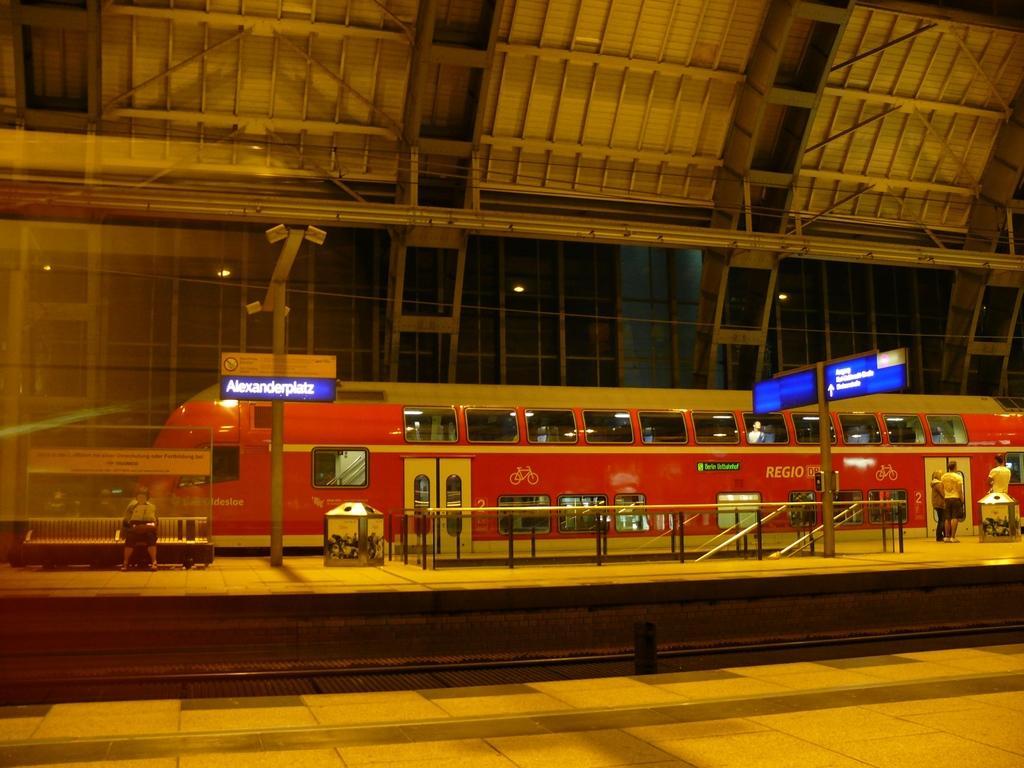Please provide a concise description of this image. In this picture, we can see a few people on the platform, and a few in a train, we can see railtrack, platform, railing, dustbins, poles, and we can see posters, lights, and we can see the roof with poles and some objects attached to it. 